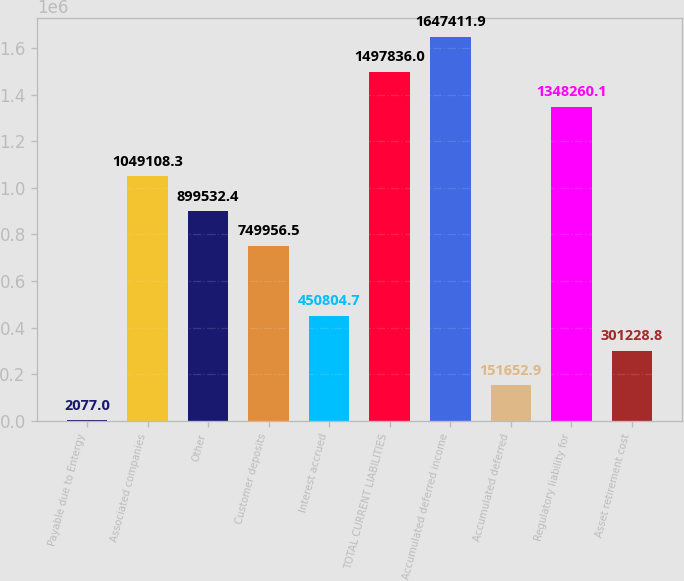Convert chart to OTSL. <chart><loc_0><loc_0><loc_500><loc_500><bar_chart><fcel>Payable due to Entergy<fcel>Associated companies<fcel>Other<fcel>Customer deposits<fcel>Interest accrued<fcel>TOTAL CURRENT LIABILITIES<fcel>Accumulated deferred income<fcel>Accumulated deferred<fcel>Regulatory liability for<fcel>Asset retirement cost<nl><fcel>2077<fcel>1.04911e+06<fcel>899532<fcel>749956<fcel>450805<fcel>1.49784e+06<fcel>1.64741e+06<fcel>151653<fcel>1.34826e+06<fcel>301229<nl></chart> 